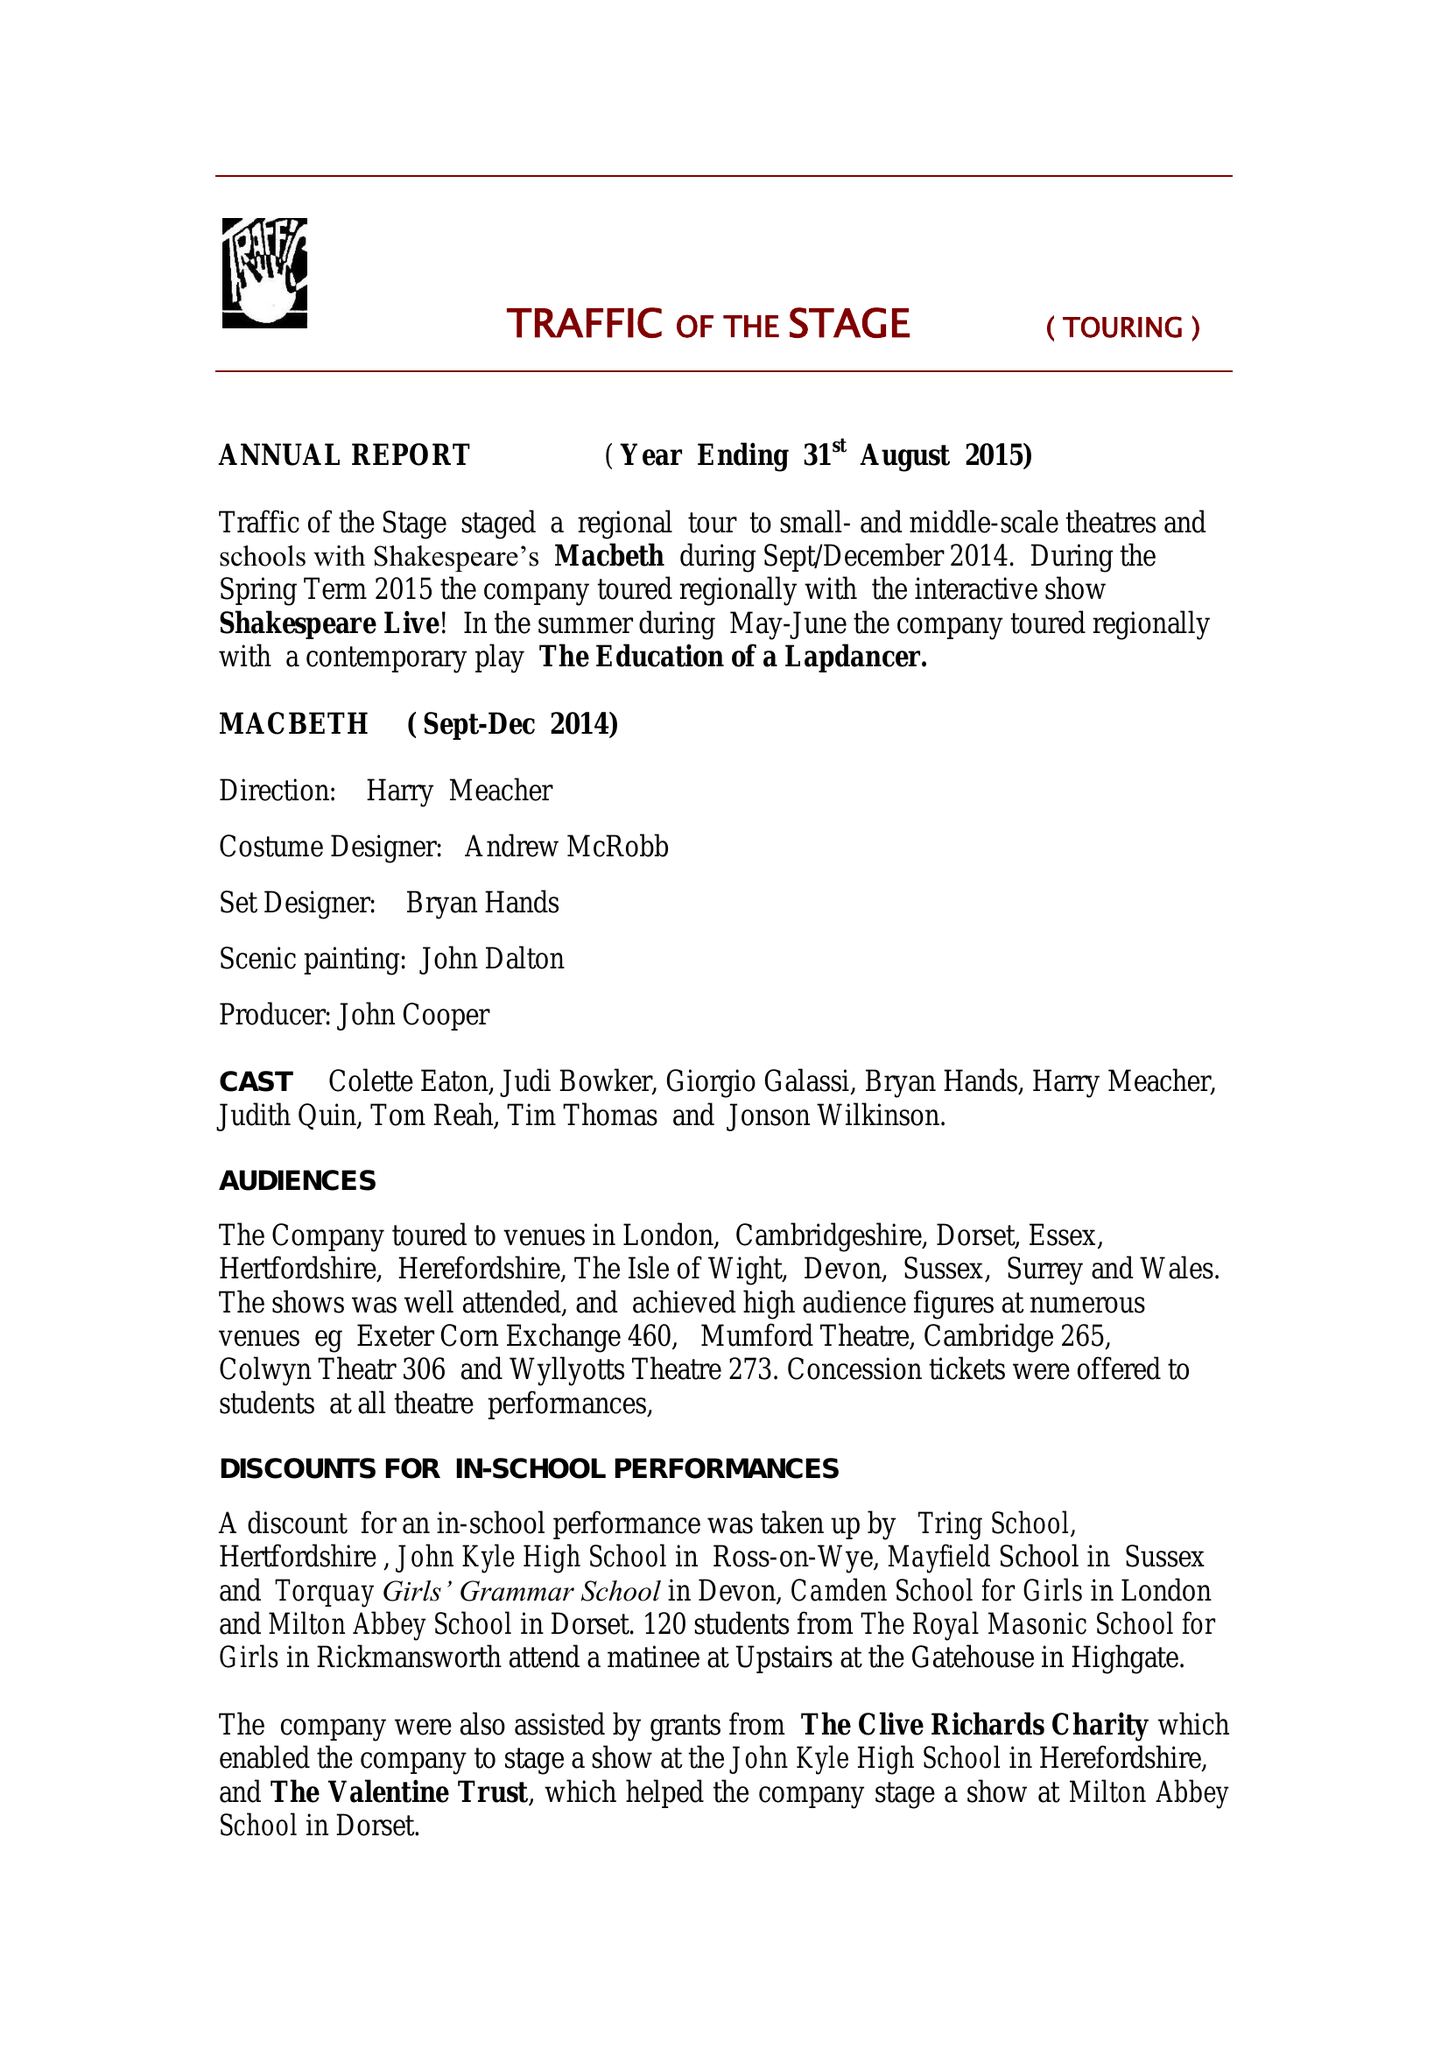What is the value for the address__postcode?
Answer the question using a single word or phrase. EX38 8PH 